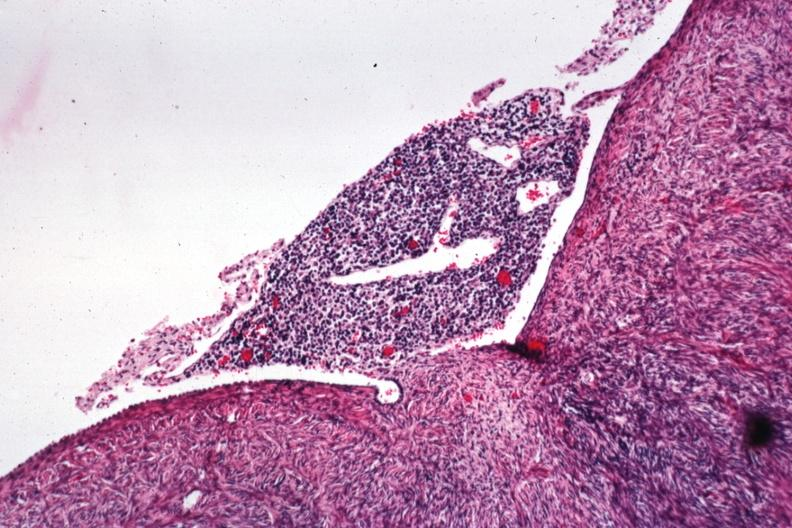s malignant lymphoma present?
Answer the question using a single word or phrase. Yes 